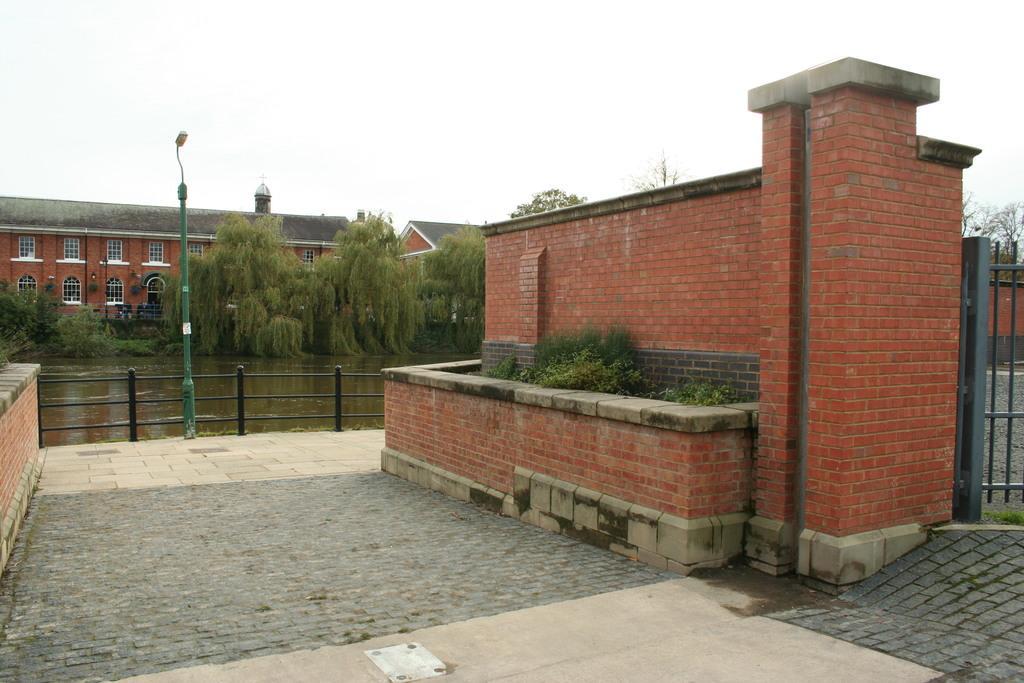In one or two sentences, can you explain what this image depicts? In this image we can see buildings, walls, light poles, trees, plants, gate, also we can see the water, and the sky. 